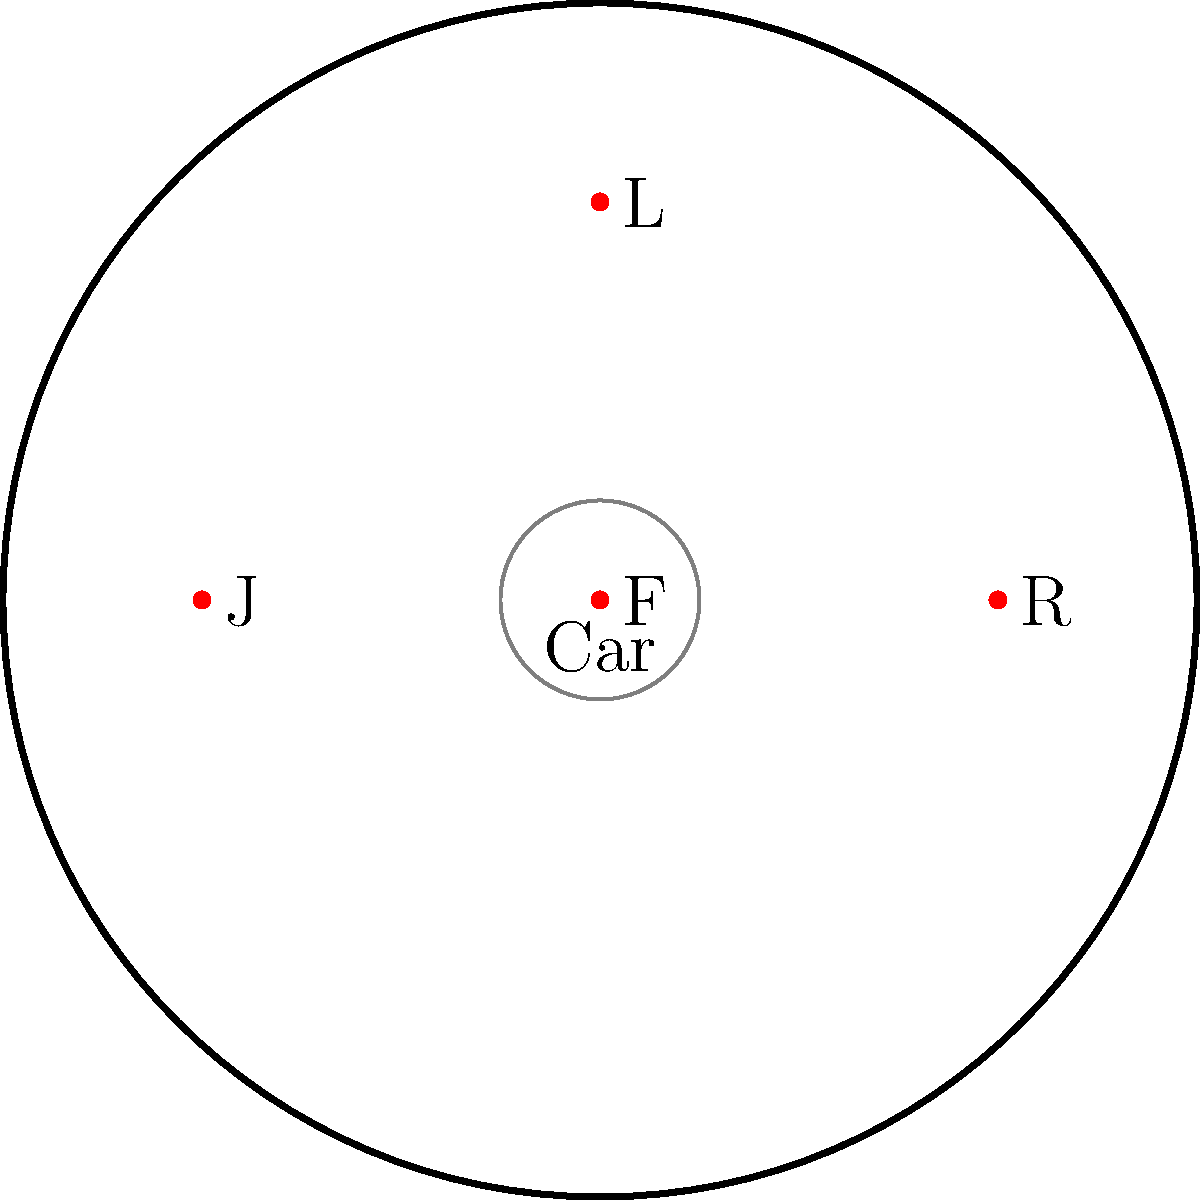In the diagram, four pit crew members are positioned around a car during a tire change. The positions are labeled F (Front), R (Right), L (Left), and J (Jack operator). Which position should be responsible for removing and replacing the right front tire to ensure the most efficient pit stop? To determine the optimal position for changing the right front tire, we need to consider the following factors:

1. Proximity to the tire: The crew member should be as close as possible to the tire they're changing to minimize movement and save time.

2. Interference with other crew members: The position should not obstruct or interfere with other crew members' tasks.

3. Access to tools and new tire: The crew member should have easy access to necessary tools and the replacement tire.

4. Safety: The position should allow the crew member to work safely without risk of injury from the car or other crew members.

Analyzing the diagram:

1. Position F (Front): Too far from the right front tire, would have to reach across the car.
2. Position R (Right): Closest to the right front tire, providing direct access.
3. Position L (Left): On the opposite side of the car, not suitable for right tire changes.
4. Position J (Jack operator): Responsible for lifting the car, not ideal for tire changes.

Based on these considerations, position R (Right) is the optimal choice for changing the right front tire. It provides the closest access to the tire, minimizes movement, and allows for efficient coordination with other crew members.
Answer: R (Right) 